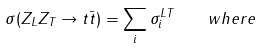<formula> <loc_0><loc_0><loc_500><loc_500>\sigma ( Z _ { L } Z _ { T } \rightarrow t \bar { t } ) = \sum _ { i } \sigma _ { i } ^ { L T } \quad w h e r e</formula> 